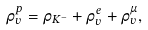<formula> <loc_0><loc_0><loc_500><loc_500>\rho _ { v } ^ { p } = \rho _ { K ^ { - } } + \rho _ { v } ^ { e } + \rho _ { v } ^ { \mu } ,</formula> 